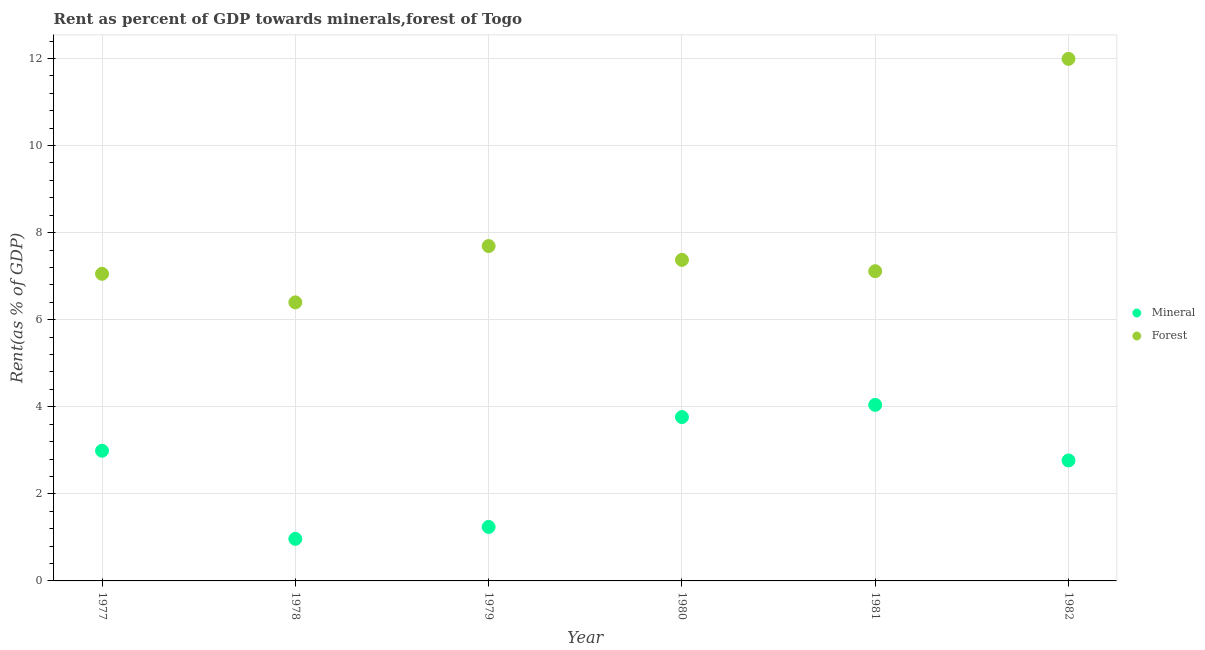How many different coloured dotlines are there?
Keep it short and to the point. 2. What is the forest rent in 1981?
Your response must be concise. 7.11. Across all years, what is the maximum mineral rent?
Make the answer very short. 4.04. Across all years, what is the minimum forest rent?
Offer a terse response. 6.4. In which year was the mineral rent maximum?
Your answer should be compact. 1981. In which year was the mineral rent minimum?
Offer a very short reply. 1978. What is the total mineral rent in the graph?
Offer a terse response. 15.77. What is the difference between the mineral rent in 1978 and that in 1982?
Offer a very short reply. -1.8. What is the difference between the mineral rent in 1978 and the forest rent in 1977?
Give a very brief answer. -6.09. What is the average mineral rent per year?
Provide a succinct answer. 2.63. In the year 1977, what is the difference between the forest rent and mineral rent?
Keep it short and to the point. 4.06. What is the ratio of the forest rent in 1978 to that in 1980?
Ensure brevity in your answer.  0.87. Is the forest rent in 1977 less than that in 1982?
Your answer should be compact. Yes. What is the difference between the highest and the second highest forest rent?
Your answer should be compact. 4.3. What is the difference between the highest and the lowest mineral rent?
Keep it short and to the point. 3.08. In how many years, is the forest rent greater than the average forest rent taken over all years?
Offer a very short reply. 1. Is the mineral rent strictly greater than the forest rent over the years?
Ensure brevity in your answer.  No. How many dotlines are there?
Keep it short and to the point. 2. How many years are there in the graph?
Provide a succinct answer. 6. Does the graph contain grids?
Your answer should be very brief. Yes. How are the legend labels stacked?
Offer a terse response. Vertical. What is the title of the graph?
Provide a succinct answer. Rent as percent of GDP towards minerals,forest of Togo. What is the label or title of the X-axis?
Offer a terse response. Year. What is the label or title of the Y-axis?
Provide a succinct answer. Rent(as % of GDP). What is the Rent(as % of GDP) of Mineral in 1977?
Ensure brevity in your answer.  2.99. What is the Rent(as % of GDP) of Forest in 1977?
Your answer should be compact. 7.05. What is the Rent(as % of GDP) of Mineral in 1978?
Your answer should be very brief. 0.97. What is the Rent(as % of GDP) in Forest in 1978?
Make the answer very short. 6.4. What is the Rent(as % of GDP) in Mineral in 1979?
Your answer should be compact. 1.24. What is the Rent(as % of GDP) of Forest in 1979?
Provide a short and direct response. 7.69. What is the Rent(as % of GDP) of Mineral in 1980?
Offer a terse response. 3.76. What is the Rent(as % of GDP) in Forest in 1980?
Your answer should be very brief. 7.37. What is the Rent(as % of GDP) of Mineral in 1981?
Offer a terse response. 4.04. What is the Rent(as % of GDP) in Forest in 1981?
Offer a very short reply. 7.11. What is the Rent(as % of GDP) of Mineral in 1982?
Your answer should be compact. 2.77. What is the Rent(as % of GDP) in Forest in 1982?
Provide a succinct answer. 11.99. Across all years, what is the maximum Rent(as % of GDP) of Mineral?
Ensure brevity in your answer.  4.04. Across all years, what is the maximum Rent(as % of GDP) in Forest?
Offer a very short reply. 11.99. Across all years, what is the minimum Rent(as % of GDP) of Mineral?
Your response must be concise. 0.97. Across all years, what is the minimum Rent(as % of GDP) of Forest?
Make the answer very short. 6.4. What is the total Rent(as % of GDP) of Mineral in the graph?
Your answer should be very brief. 15.77. What is the total Rent(as % of GDP) of Forest in the graph?
Provide a succinct answer. 47.62. What is the difference between the Rent(as % of GDP) of Mineral in 1977 and that in 1978?
Keep it short and to the point. 2.02. What is the difference between the Rent(as % of GDP) of Forest in 1977 and that in 1978?
Ensure brevity in your answer.  0.66. What is the difference between the Rent(as % of GDP) of Mineral in 1977 and that in 1979?
Make the answer very short. 1.75. What is the difference between the Rent(as % of GDP) in Forest in 1977 and that in 1979?
Your answer should be compact. -0.64. What is the difference between the Rent(as % of GDP) in Mineral in 1977 and that in 1980?
Give a very brief answer. -0.77. What is the difference between the Rent(as % of GDP) in Forest in 1977 and that in 1980?
Provide a succinct answer. -0.32. What is the difference between the Rent(as % of GDP) of Mineral in 1977 and that in 1981?
Offer a terse response. -1.05. What is the difference between the Rent(as % of GDP) of Forest in 1977 and that in 1981?
Your answer should be compact. -0.06. What is the difference between the Rent(as % of GDP) of Mineral in 1977 and that in 1982?
Your response must be concise. 0.22. What is the difference between the Rent(as % of GDP) of Forest in 1977 and that in 1982?
Your answer should be very brief. -4.94. What is the difference between the Rent(as % of GDP) of Mineral in 1978 and that in 1979?
Your answer should be very brief. -0.27. What is the difference between the Rent(as % of GDP) of Forest in 1978 and that in 1979?
Your response must be concise. -1.29. What is the difference between the Rent(as % of GDP) in Mineral in 1978 and that in 1980?
Ensure brevity in your answer.  -2.8. What is the difference between the Rent(as % of GDP) of Forest in 1978 and that in 1980?
Ensure brevity in your answer.  -0.98. What is the difference between the Rent(as % of GDP) of Mineral in 1978 and that in 1981?
Offer a very short reply. -3.08. What is the difference between the Rent(as % of GDP) in Forest in 1978 and that in 1981?
Your answer should be very brief. -0.72. What is the difference between the Rent(as % of GDP) of Mineral in 1978 and that in 1982?
Ensure brevity in your answer.  -1.8. What is the difference between the Rent(as % of GDP) of Forest in 1978 and that in 1982?
Your answer should be very brief. -5.59. What is the difference between the Rent(as % of GDP) in Mineral in 1979 and that in 1980?
Your response must be concise. -2.52. What is the difference between the Rent(as % of GDP) in Forest in 1979 and that in 1980?
Keep it short and to the point. 0.32. What is the difference between the Rent(as % of GDP) of Mineral in 1979 and that in 1981?
Offer a very short reply. -2.8. What is the difference between the Rent(as % of GDP) in Forest in 1979 and that in 1981?
Keep it short and to the point. 0.58. What is the difference between the Rent(as % of GDP) in Mineral in 1979 and that in 1982?
Keep it short and to the point. -1.53. What is the difference between the Rent(as % of GDP) of Forest in 1979 and that in 1982?
Give a very brief answer. -4.3. What is the difference between the Rent(as % of GDP) in Mineral in 1980 and that in 1981?
Ensure brevity in your answer.  -0.28. What is the difference between the Rent(as % of GDP) of Forest in 1980 and that in 1981?
Your answer should be compact. 0.26. What is the difference between the Rent(as % of GDP) in Mineral in 1980 and that in 1982?
Give a very brief answer. 1. What is the difference between the Rent(as % of GDP) of Forest in 1980 and that in 1982?
Make the answer very short. -4.62. What is the difference between the Rent(as % of GDP) in Mineral in 1981 and that in 1982?
Offer a terse response. 1.28. What is the difference between the Rent(as % of GDP) in Forest in 1981 and that in 1982?
Ensure brevity in your answer.  -4.88. What is the difference between the Rent(as % of GDP) of Mineral in 1977 and the Rent(as % of GDP) of Forest in 1978?
Your answer should be compact. -3.41. What is the difference between the Rent(as % of GDP) in Mineral in 1977 and the Rent(as % of GDP) in Forest in 1979?
Provide a succinct answer. -4.7. What is the difference between the Rent(as % of GDP) of Mineral in 1977 and the Rent(as % of GDP) of Forest in 1980?
Your response must be concise. -4.38. What is the difference between the Rent(as % of GDP) of Mineral in 1977 and the Rent(as % of GDP) of Forest in 1981?
Give a very brief answer. -4.12. What is the difference between the Rent(as % of GDP) of Mineral in 1977 and the Rent(as % of GDP) of Forest in 1982?
Your response must be concise. -9. What is the difference between the Rent(as % of GDP) of Mineral in 1978 and the Rent(as % of GDP) of Forest in 1979?
Give a very brief answer. -6.73. What is the difference between the Rent(as % of GDP) of Mineral in 1978 and the Rent(as % of GDP) of Forest in 1980?
Provide a succinct answer. -6.41. What is the difference between the Rent(as % of GDP) of Mineral in 1978 and the Rent(as % of GDP) of Forest in 1981?
Provide a succinct answer. -6.15. What is the difference between the Rent(as % of GDP) of Mineral in 1978 and the Rent(as % of GDP) of Forest in 1982?
Provide a short and direct response. -11.02. What is the difference between the Rent(as % of GDP) of Mineral in 1979 and the Rent(as % of GDP) of Forest in 1980?
Your answer should be very brief. -6.13. What is the difference between the Rent(as % of GDP) of Mineral in 1979 and the Rent(as % of GDP) of Forest in 1981?
Keep it short and to the point. -5.87. What is the difference between the Rent(as % of GDP) in Mineral in 1979 and the Rent(as % of GDP) in Forest in 1982?
Keep it short and to the point. -10.75. What is the difference between the Rent(as % of GDP) in Mineral in 1980 and the Rent(as % of GDP) in Forest in 1981?
Give a very brief answer. -3.35. What is the difference between the Rent(as % of GDP) in Mineral in 1980 and the Rent(as % of GDP) in Forest in 1982?
Provide a succinct answer. -8.23. What is the difference between the Rent(as % of GDP) in Mineral in 1981 and the Rent(as % of GDP) in Forest in 1982?
Ensure brevity in your answer.  -7.95. What is the average Rent(as % of GDP) in Mineral per year?
Ensure brevity in your answer.  2.63. What is the average Rent(as % of GDP) of Forest per year?
Provide a succinct answer. 7.94. In the year 1977, what is the difference between the Rent(as % of GDP) in Mineral and Rent(as % of GDP) in Forest?
Ensure brevity in your answer.  -4.06. In the year 1978, what is the difference between the Rent(as % of GDP) in Mineral and Rent(as % of GDP) in Forest?
Your answer should be very brief. -5.43. In the year 1979, what is the difference between the Rent(as % of GDP) in Mineral and Rent(as % of GDP) in Forest?
Make the answer very short. -6.45. In the year 1980, what is the difference between the Rent(as % of GDP) in Mineral and Rent(as % of GDP) in Forest?
Offer a very short reply. -3.61. In the year 1981, what is the difference between the Rent(as % of GDP) in Mineral and Rent(as % of GDP) in Forest?
Provide a short and direct response. -3.07. In the year 1982, what is the difference between the Rent(as % of GDP) of Mineral and Rent(as % of GDP) of Forest?
Provide a short and direct response. -9.22. What is the ratio of the Rent(as % of GDP) of Mineral in 1977 to that in 1978?
Ensure brevity in your answer.  3.1. What is the ratio of the Rent(as % of GDP) of Forest in 1977 to that in 1978?
Offer a very short reply. 1.1. What is the ratio of the Rent(as % of GDP) in Mineral in 1977 to that in 1979?
Make the answer very short. 2.41. What is the ratio of the Rent(as % of GDP) of Forest in 1977 to that in 1979?
Give a very brief answer. 0.92. What is the ratio of the Rent(as % of GDP) of Mineral in 1977 to that in 1980?
Give a very brief answer. 0.79. What is the ratio of the Rent(as % of GDP) in Forest in 1977 to that in 1980?
Your response must be concise. 0.96. What is the ratio of the Rent(as % of GDP) in Mineral in 1977 to that in 1981?
Offer a terse response. 0.74. What is the ratio of the Rent(as % of GDP) of Forest in 1977 to that in 1981?
Offer a terse response. 0.99. What is the ratio of the Rent(as % of GDP) of Mineral in 1977 to that in 1982?
Offer a terse response. 1.08. What is the ratio of the Rent(as % of GDP) in Forest in 1977 to that in 1982?
Provide a succinct answer. 0.59. What is the ratio of the Rent(as % of GDP) in Mineral in 1978 to that in 1979?
Offer a very short reply. 0.78. What is the ratio of the Rent(as % of GDP) of Forest in 1978 to that in 1979?
Your answer should be compact. 0.83. What is the ratio of the Rent(as % of GDP) in Mineral in 1978 to that in 1980?
Make the answer very short. 0.26. What is the ratio of the Rent(as % of GDP) of Forest in 1978 to that in 1980?
Your answer should be compact. 0.87. What is the ratio of the Rent(as % of GDP) of Mineral in 1978 to that in 1981?
Keep it short and to the point. 0.24. What is the ratio of the Rent(as % of GDP) in Forest in 1978 to that in 1981?
Your answer should be very brief. 0.9. What is the ratio of the Rent(as % of GDP) in Mineral in 1978 to that in 1982?
Provide a short and direct response. 0.35. What is the ratio of the Rent(as % of GDP) of Forest in 1978 to that in 1982?
Give a very brief answer. 0.53. What is the ratio of the Rent(as % of GDP) in Mineral in 1979 to that in 1980?
Your answer should be very brief. 0.33. What is the ratio of the Rent(as % of GDP) of Forest in 1979 to that in 1980?
Offer a terse response. 1.04. What is the ratio of the Rent(as % of GDP) of Mineral in 1979 to that in 1981?
Your answer should be very brief. 0.31. What is the ratio of the Rent(as % of GDP) of Forest in 1979 to that in 1981?
Offer a very short reply. 1.08. What is the ratio of the Rent(as % of GDP) of Mineral in 1979 to that in 1982?
Give a very brief answer. 0.45. What is the ratio of the Rent(as % of GDP) of Forest in 1979 to that in 1982?
Keep it short and to the point. 0.64. What is the ratio of the Rent(as % of GDP) in Mineral in 1980 to that in 1981?
Offer a very short reply. 0.93. What is the ratio of the Rent(as % of GDP) in Forest in 1980 to that in 1981?
Your answer should be very brief. 1.04. What is the ratio of the Rent(as % of GDP) in Mineral in 1980 to that in 1982?
Your answer should be very brief. 1.36. What is the ratio of the Rent(as % of GDP) in Forest in 1980 to that in 1982?
Your answer should be very brief. 0.61. What is the ratio of the Rent(as % of GDP) in Mineral in 1981 to that in 1982?
Make the answer very short. 1.46. What is the ratio of the Rent(as % of GDP) of Forest in 1981 to that in 1982?
Provide a succinct answer. 0.59. What is the difference between the highest and the second highest Rent(as % of GDP) of Mineral?
Give a very brief answer. 0.28. What is the difference between the highest and the second highest Rent(as % of GDP) of Forest?
Keep it short and to the point. 4.3. What is the difference between the highest and the lowest Rent(as % of GDP) in Mineral?
Provide a succinct answer. 3.08. What is the difference between the highest and the lowest Rent(as % of GDP) of Forest?
Offer a very short reply. 5.59. 